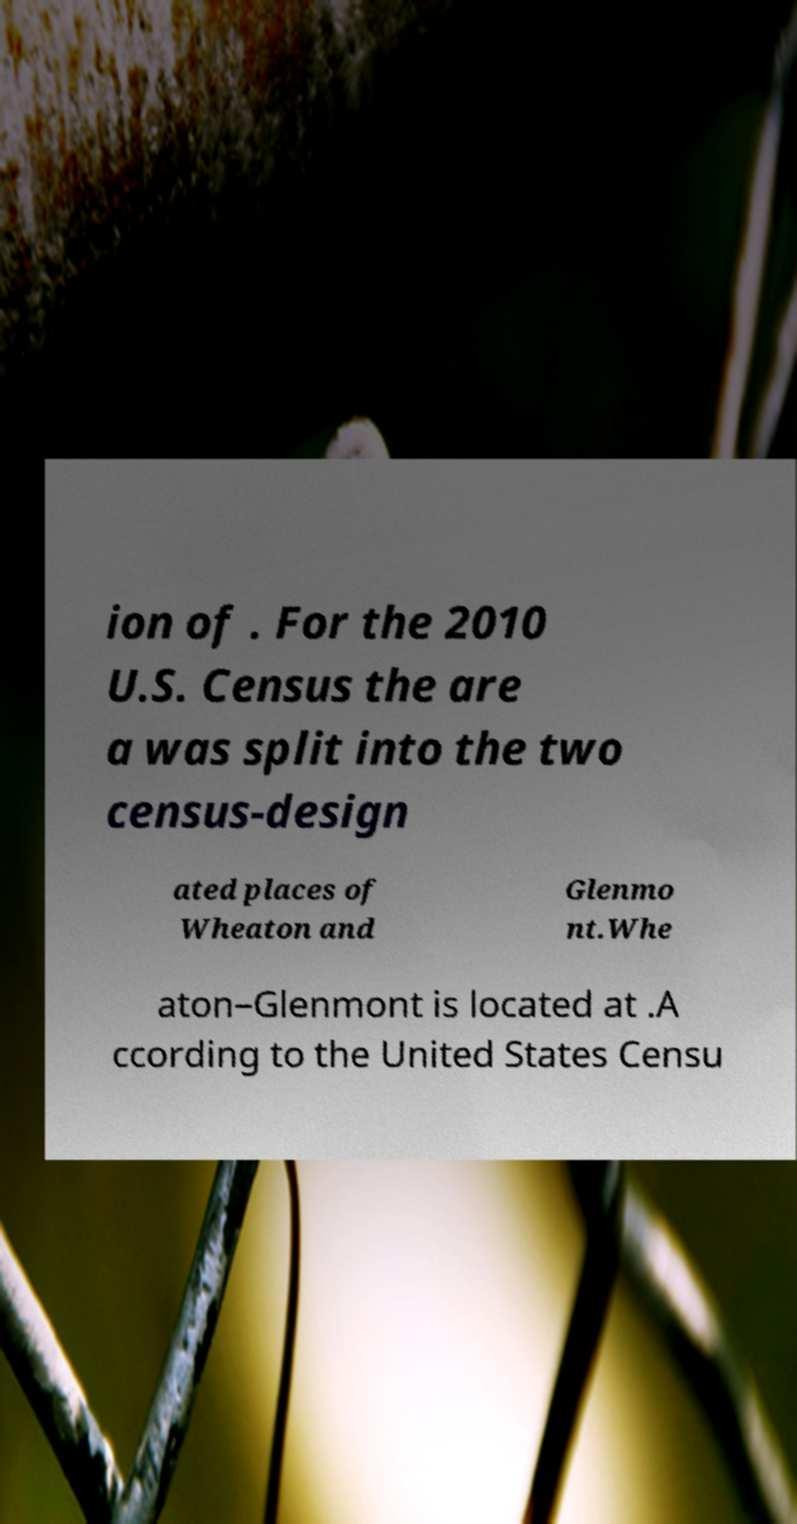Could you assist in decoding the text presented in this image and type it out clearly? ion of . For the 2010 U.S. Census the are a was split into the two census-design ated places of Wheaton and Glenmo nt.Whe aton–Glenmont is located at .A ccording to the United States Censu 